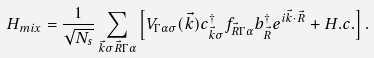<formula> <loc_0><loc_0><loc_500><loc_500>H _ { m i x } = \frac { 1 } { \sqrt { N _ { s } } } \sum _ { \vec { k } \sigma \vec { R } \Gamma \alpha } \left [ V _ { \Gamma \alpha \sigma } ( \vec { k } ) c ^ { \dagger } _ { \vec { k } \sigma } f _ { \vec { R } \Gamma \alpha } b ^ { \dagger } _ { \vec { R } } e ^ { i \vec { k } \cdot \vec { R } } + H . c . \right ] .</formula> 